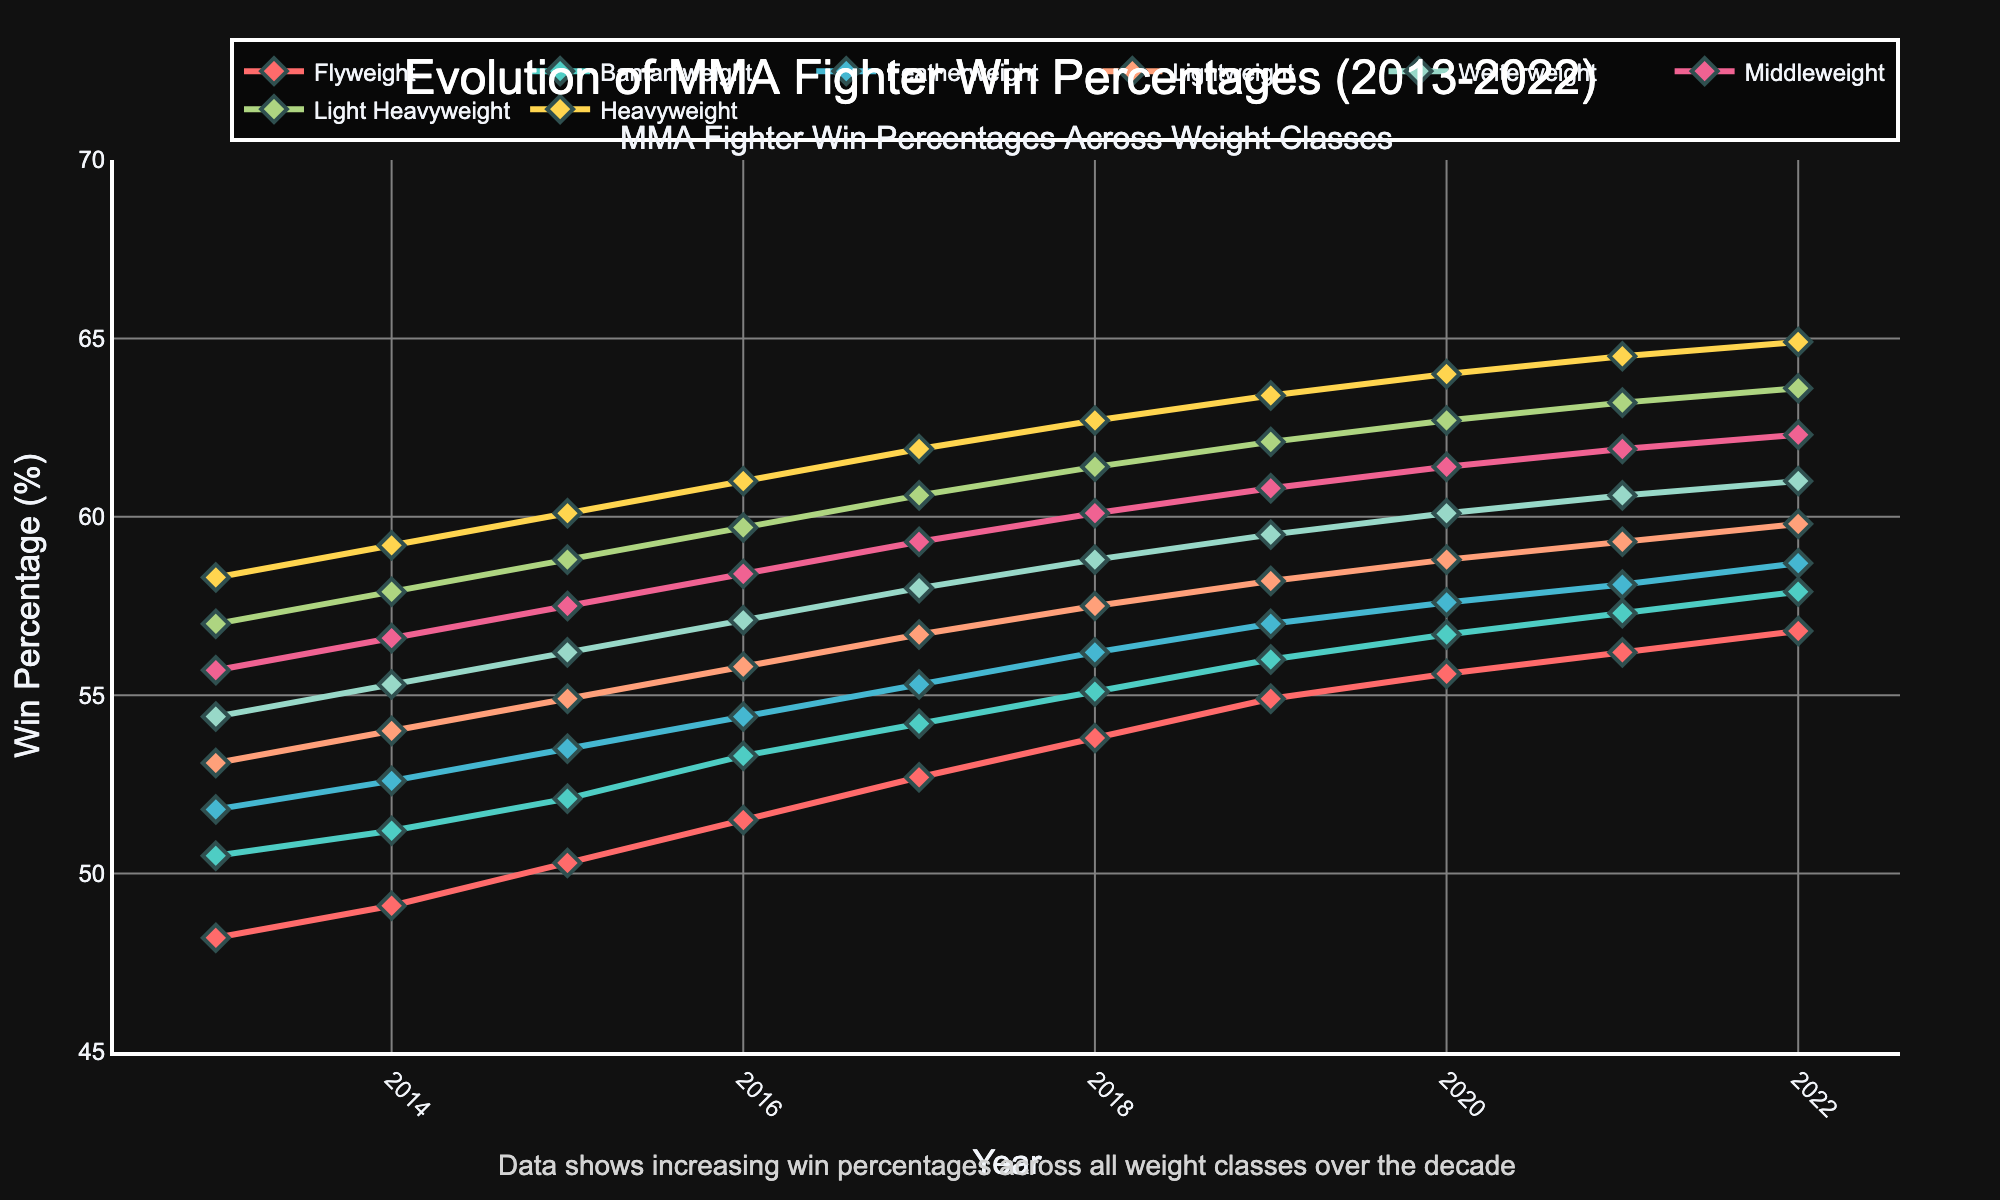What is the trend in win percentages for the Flyweight class from 2013 to 2022? The trend can be determined by examining the line corresponding to the Flyweight class over the years from 2013 to 2022. The line shows a continuous upward trajectory from 48.2% in 2013 to 56.8% in 2022. This indicates an increase in win percentages over time.
Answer: Increasing trend Which weight class had the highest win percentage in 2022? To find the weight class with the highest win percentage in 2022, look for the peak among the lines on the far right of the chart. The line for the Heavyweight class ends at 64.9%, which is higher than the other classes.
Answer: Heavyweight Between which consecutive years did the Middleweight class see the largest increase in win percentage? To determine this, calculate the differences in win percentages for the Middleweight class between consecutive years and find the largest difference. The differences are: 0.9 (2013-2014), 0.9 (2014-2015), 0.9 (2015-2016), 0.9 (2016-2017), 0.8 (2017-2018), 0.7 (2018-2019), 0.6 (2019-2020), 0.5 (2020-2021), and 0.4 (2021-2022). The largest increase is 0.9%, occurring multiple times.
Answer: 2013-2014 How does the win percentage of the Featherweight class in 2017 compare to that in 2022? Compare the values of the Featherweight class for the years 2017 and 2022 by looking at the corresponding points on the chart. In 2017, the percentage is 55.3%, and in 2022, it is 58.7%. Calculate the difference to find the change.
Answer: It increased by 3.4% What is the average win percentage of the Lightweight class over the decade? To find the average win percentage over the decade for the Lightweight class, sum the yearly percentages and divide by the number of years. The values for 2013 to 2022 are: 53.1, 54.0, 54.9, 55.8, 56.7, 57.5, 58.2, 58.8, 59.3, 59.8. Sum these values to get 568.1, then divide by 10.
Answer: 56.81% Which weight class had the most significant improvement in win percentage from 2013 to 2022? Find the difference between the 2013 and 2022 win percentages for each weight class. The differences are: Flyweight (8.6), Bantamweight (7.4), Featherweight (6.9), Lightweight (6.7), Welterweight (6.6), Middleweight (6.6), Light Heavyweight (6.6), Heavyweight (6.6). The Flyweight class has the largest difference.
Answer: Flyweight What color represents the Heavyweight class in the chart? The color corresponding to the Heavyweight class is displayed in the chart legend. The Heavyweight class line is visually represented by a yellow color.
Answer: Yellow Does any weight class have a decreasing trend in win percentages over the decade? Examine the overall direction of each line from 2013 to 2022. Every line shows an upward trajectory, indicating that all classes experienced an increase in win percentages over the decade.
Answer: No How did the win percentage of the Light Heavyweight class change from 2018 to 2019? Look at the points for the Light Heavyweight class in 2018 and 2019. In 2018, the percentage is 61.4%, and in 2019, it is 62.1%. Subtracting 61.4 from 62.1 gives the change.
Answer: It increased by 0.7% 